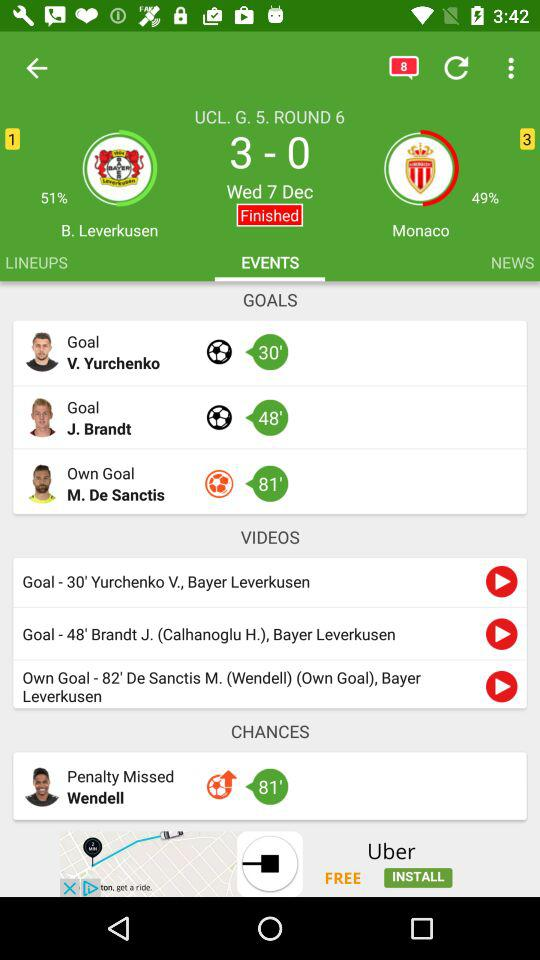Which tab is selected? The selected tab is "EVENTS". 